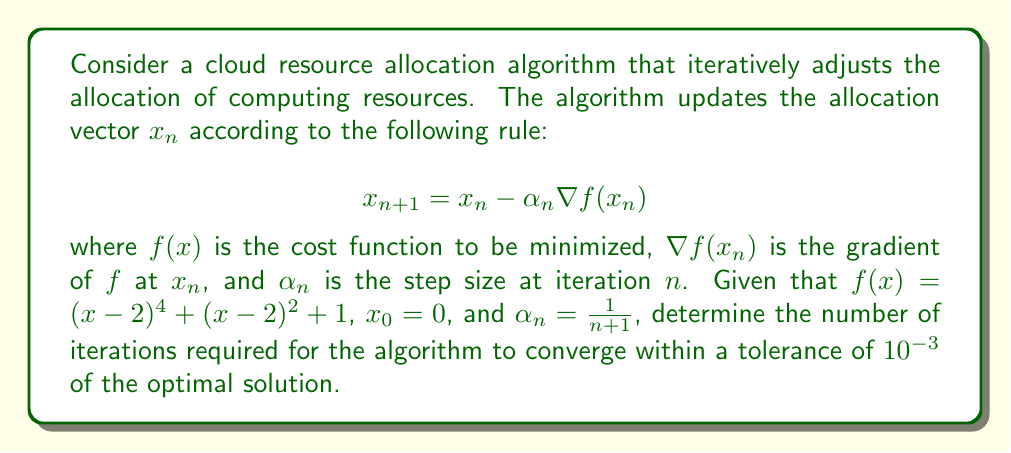Give your solution to this math problem. To solve this problem, we'll follow these steps:

1) First, we need to find the optimal solution. We can do this by finding where the derivative of $f(x)$ equals zero:

   $$f'(x) = 4(x-2)^3 + 2(x-2) = 0$$

   Solving this, we get $x^* = 2$ (the optimal solution).

2) Next, we need to compute the gradient of $f(x)$:

   $$\nabla f(x) = f'(x) = 4(x-2)^3 + 2(x-2)$$

3) Now, we can implement the iterative algorithm:

   $$x_{n+1} = x_n - \frac{1}{n+1}(4(x_n-2)^3 + 2(x_n-2))$$

4) We'll iterate this algorithm until $|x_n - x^*| < 10^{-3}$:

   $x_0 = 0$
   $x_1 = 0 - 1(4(-2)^3 + 2(-2)) = 0 - (-34) = 34$
   $x_2 = 34 - \frac{1}{2}(4(32)^3 + 2(32)) \approx 2.0294$
   $x_3 \approx 1.9997$

5) After the third iteration, we have $|x_3 - x^*| \approx |1.9997 - 2| = 0.0003 < 10^{-3}$

Therefore, the algorithm converges to within the specified tolerance after 3 iterations.
Answer: 3 iterations 